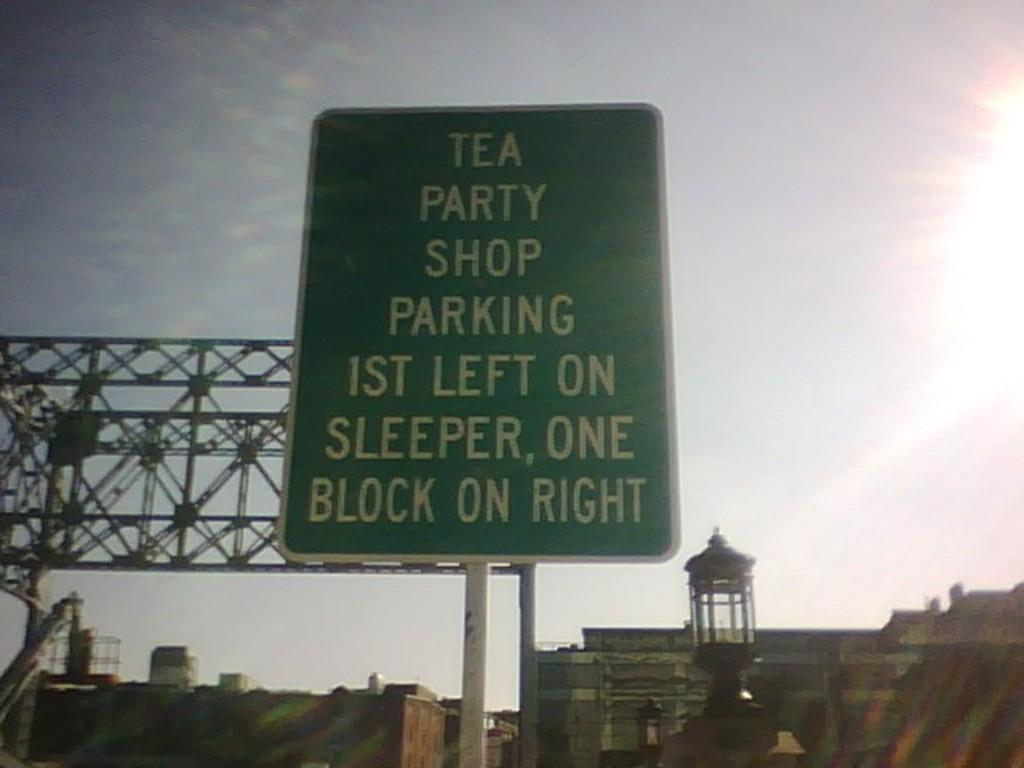<image>
Present a compact description of the photo's key features. A green and white street sign that reads tea party shop parking. 